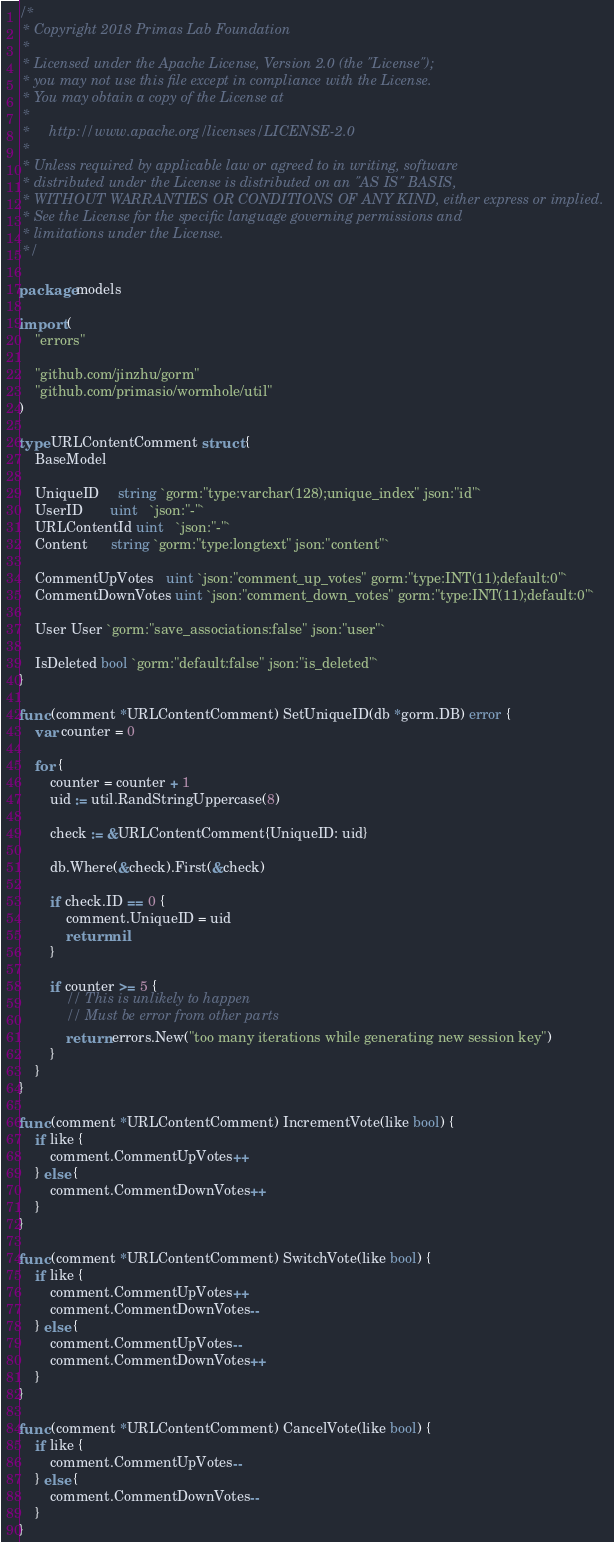Convert code to text. <code><loc_0><loc_0><loc_500><loc_500><_Go_>/*
 * Copyright 2018 Primas Lab Foundation
 *
 * Licensed under the Apache License, Version 2.0 (the "License");
 * you may not use this file except in compliance with the License.
 * You may obtain a copy of the License at
 *
 *     http://www.apache.org/licenses/LICENSE-2.0
 *
 * Unless required by applicable law or agreed to in writing, software
 * distributed under the License is distributed on an "AS IS" BASIS,
 * WITHOUT WARRANTIES OR CONDITIONS OF ANY KIND, either express or implied.
 * See the License for the specific language governing permissions and
 * limitations under the License.
 */

package models

import (
	"errors"

	"github.com/jinzhu/gorm"
	"github.com/primasio/wormhole/util"
)

type URLContentComment struct {
	BaseModel

	UniqueID     string `gorm:"type:varchar(128);unique_index" json:"id"`
	UserID       uint   `json:"-"`
	URLContentId uint   `json:"-"`
	Content      string `gorm:"type:longtext" json:"content"`

	CommentUpVotes   uint `json:"comment_up_votes" gorm:"type:INT(11);default:0"`
	CommentDownVotes uint `json:"comment_down_votes" gorm:"type:INT(11);default:0"`

	User User `gorm:"save_associations:false" json:"user"`

	IsDeleted bool `gorm:"default:false" json:"is_deleted"`
}

func (comment *URLContentComment) SetUniqueID(db *gorm.DB) error {
	var counter = 0

	for {
		counter = counter + 1
		uid := util.RandStringUppercase(8)

		check := &URLContentComment{UniqueID: uid}

		db.Where(&check).First(&check)

		if check.ID == 0 {
			comment.UniqueID = uid
			return nil
		}

		if counter >= 5 {
			// This is unlikely to happen
			// Must be error from other parts
			return errors.New("too many iterations while generating new session key")
		}
	}
}

func (comment *URLContentComment) IncrementVote(like bool) {
	if like {
		comment.CommentUpVotes++
	} else {
		comment.CommentDownVotes++
	}
}

func (comment *URLContentComment) SwitchVote(like bool) {
	if like {
		comment.CommentUpVotes++
		comment.CommentDownVotes--
	} else {
		comment.CommentUpVotes--
		comment.CommentDownVotes++
	}
}

func (comment *URLContentComment) CancelVote(like bool) {
	if like {
		comment.CommentUpVotes--
	} else {
		comment.CommentDownVotes--
	}
}
</code> 